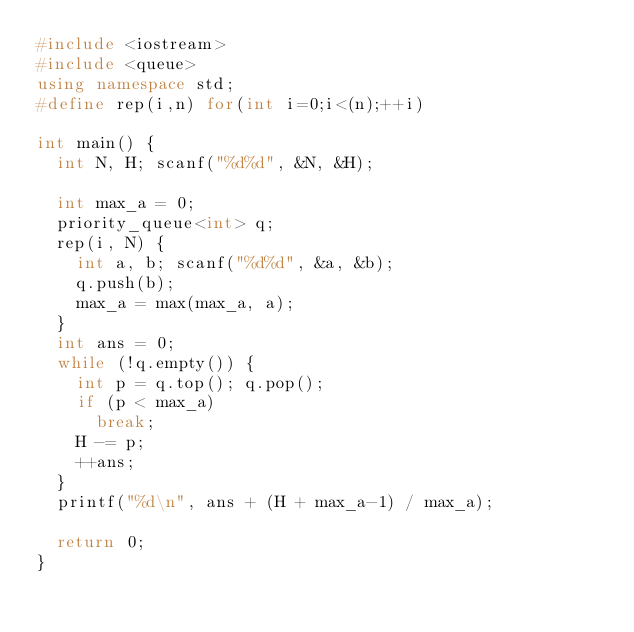Convert code to text. <code><loc_0><loc_0><loc_500><loc_500><_C++_>#include <iostream>
#include <queue>
using namespace std;
#define rep(i,n) for(int i=0;i<(n);++i)

int main() {
  int N, H; scanf("%d%d", &N, &H);

  int max_a = 0;
  priority_queue<int> q;
  rep(i, N) {
    int a, b; scanf("%d%d", &a, &b);
    q.push(b);
    max_a = max(max_a, a);
  }
  int ans = 0;
  while (!q.empty()) {
    int p = q.top(); q.pop();
    if (p < max_a)
      break;
    H -= p;
    ++ans;
  }
  printf("%d\n", ans + (H + max_a-1) / max_a);

  return 0;
}
</code> 